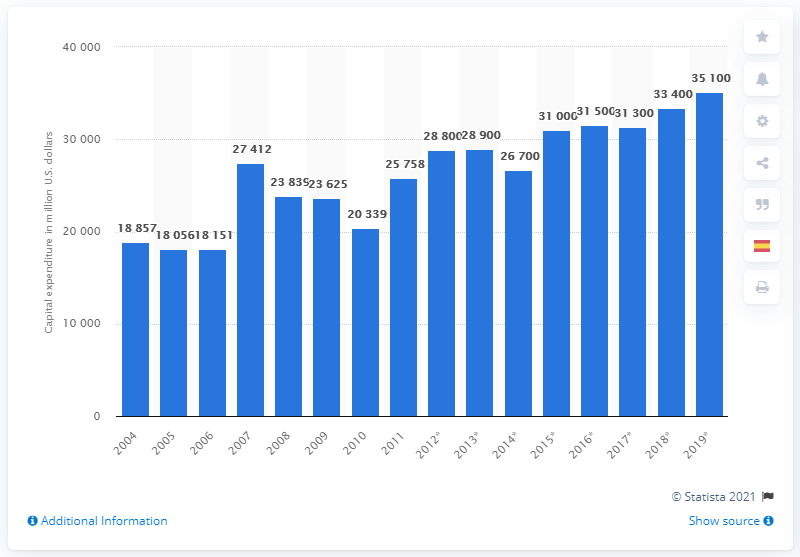Draw attention to some important aspects in this diagram. In 2019, the capital expenditure of the U.S. chemical industry was approximately $35,100. 